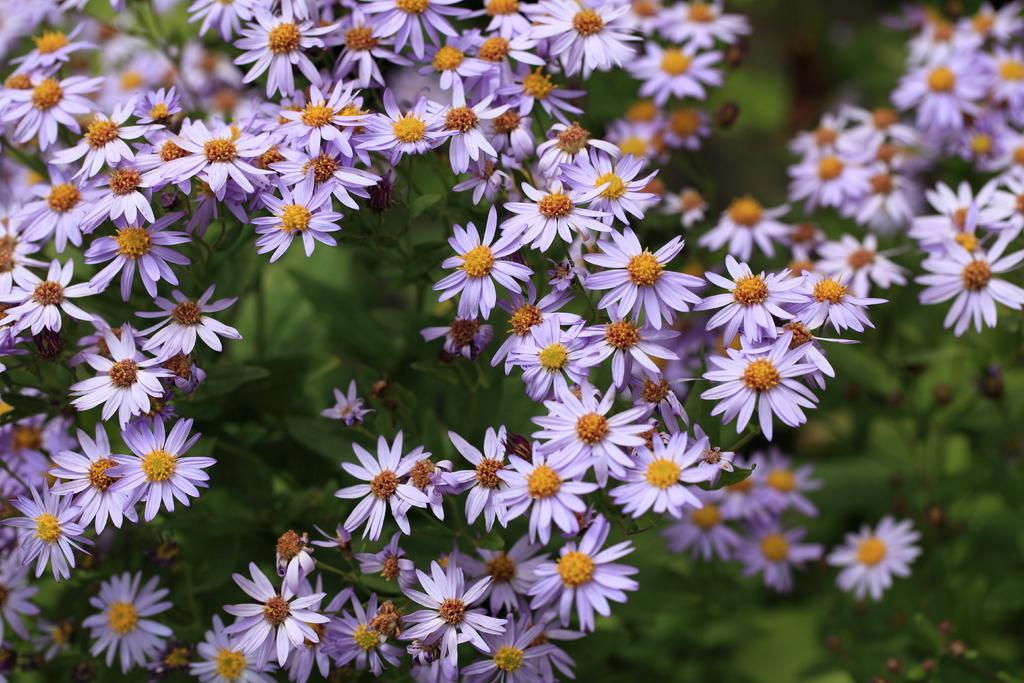What type of living organisms are in the image? There are plants in the image. What specific feature can be observed on the plants? The plants have flowers. Can you describe the background of the image? The background of the image is blurred. Is there a veil covering the plants in the image? There is no veil present in the image; the plants are not covered. How many visitors can be seen interacting with the plants in the image? There are no visitors present in the image; it only features plants with flowers. 